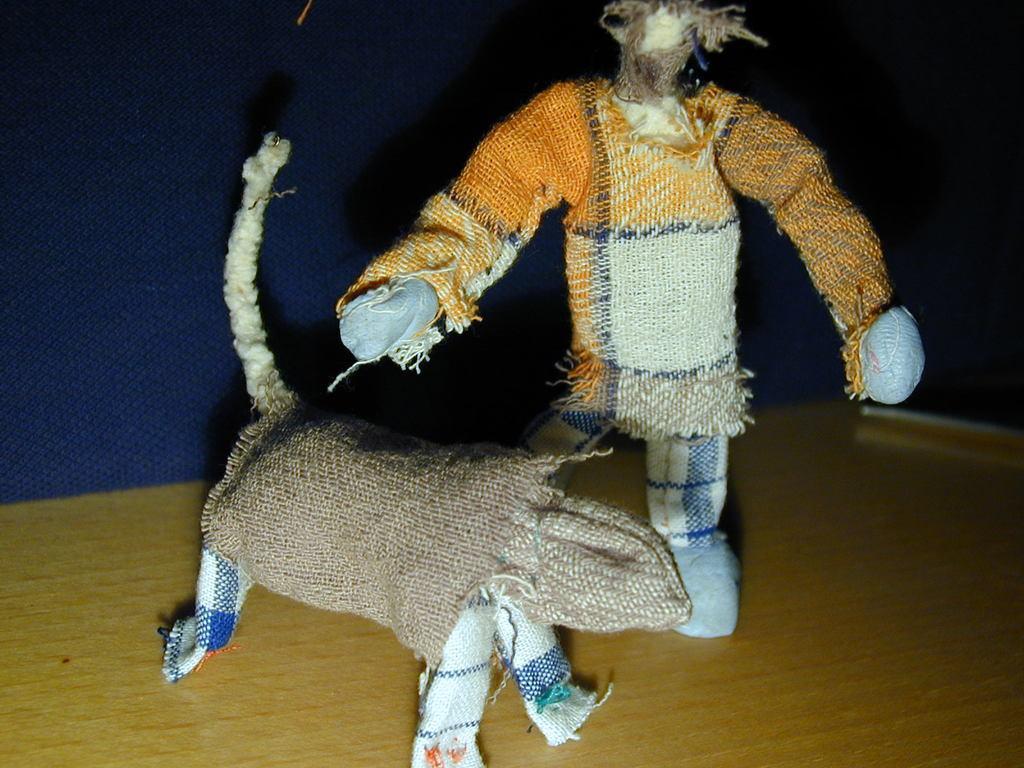Describe this image in one or two sentences. In this image there are two toys made of cloth on the floor. 